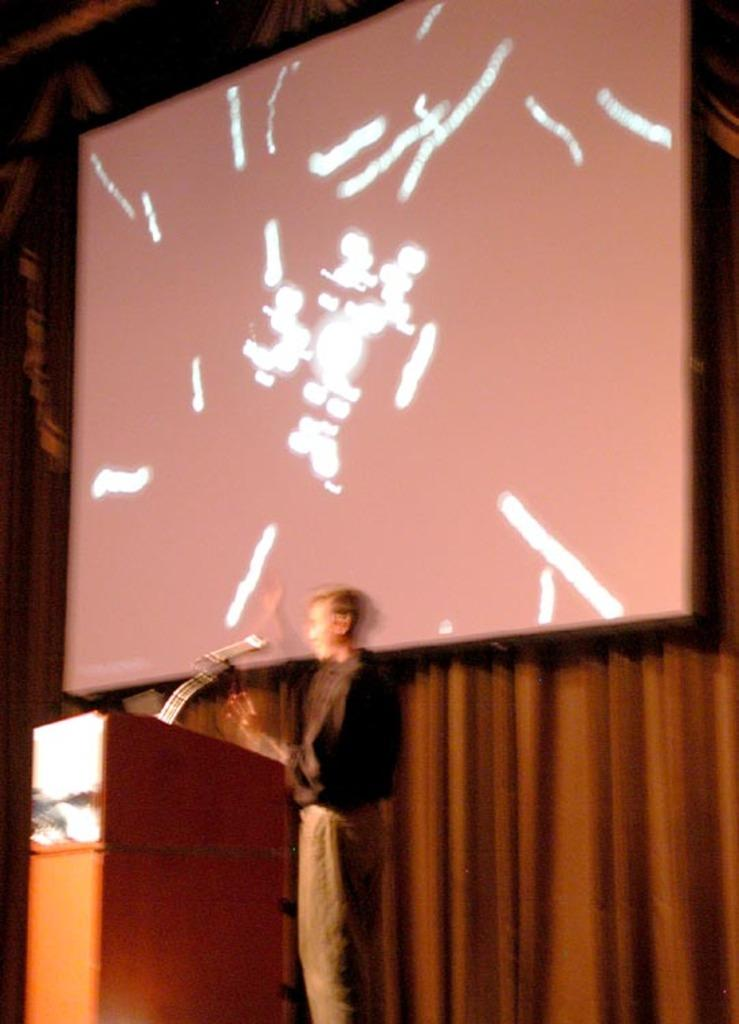What is the main subject of the image? There is a person standing in the center of the image. What is the person standing in front of? There is a podium in front of the person. What is on the podium? There is a microphone on the podium. What can be seen in the background of the image? There is a screen and a curtain in the background of the image. Can you see the person's partner in the image? There is no mention of a partner in the image, so it cannot be determined if one is present. What type of ocean can be seen in the background of the image? There is no ocean present in the image; it features a screen and a curtain in the background. 